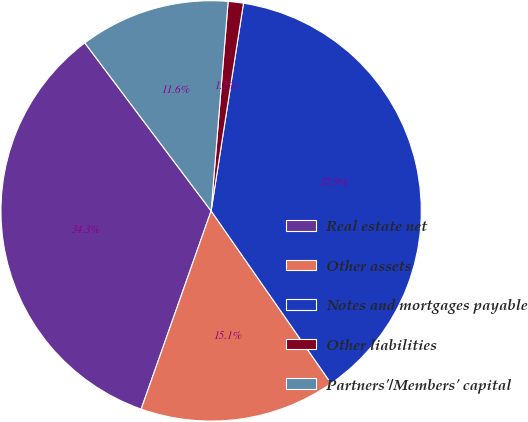<chart> <loc_0><loc_0><loc_500><loc_500><pie_chart><fcel>Real estate net<fcel>Other assets<fcel>Notes and mortgages payable<fcel>Other liabilities<fcel>Partners'/Members' capital<nl><fcel>34.34%<fcel>15.07%<fcel>37.87%<fcel>1.17%<fcel>11.55%<nl></chart> 